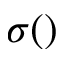Convert formula to latex. <formula><loc_0><loc_0><loc_500><loc_500>\sigma ( )</formula> 